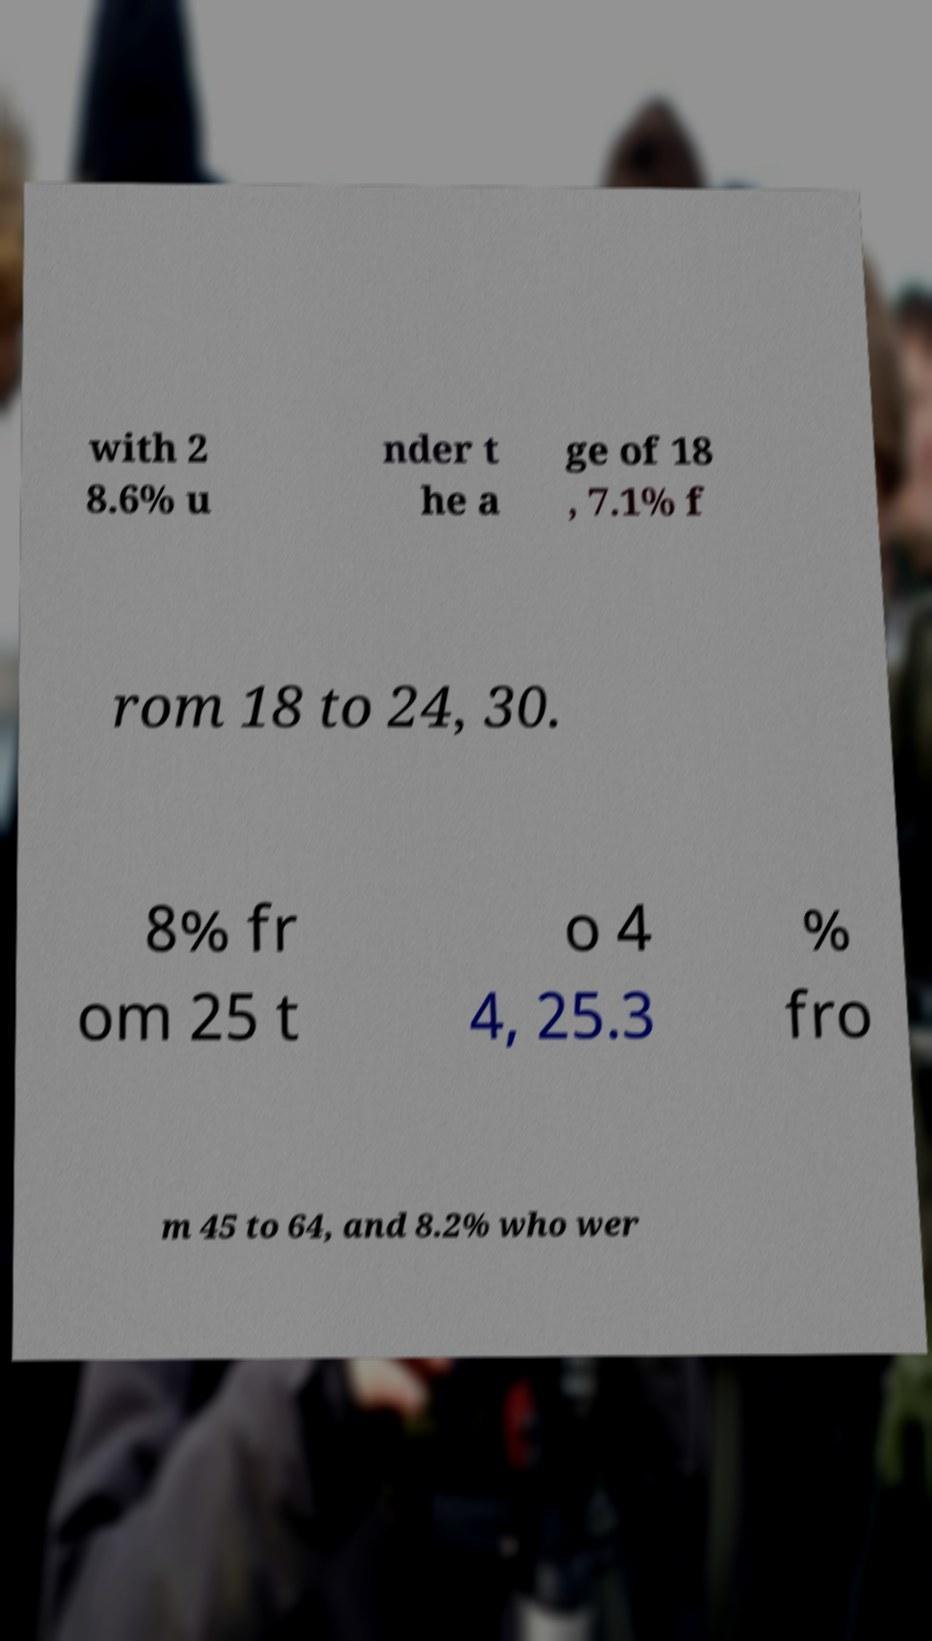For documentation purposes, I need the text within this image transcribed. Could you provide that? with 2 8.6% u nder t he a ge of 18 , 7.1% f rom 18 to 24, 30. 8% fr om 25 t o 4 4, 25.3 % fro m 45 to 64, and 8.2% who wer 